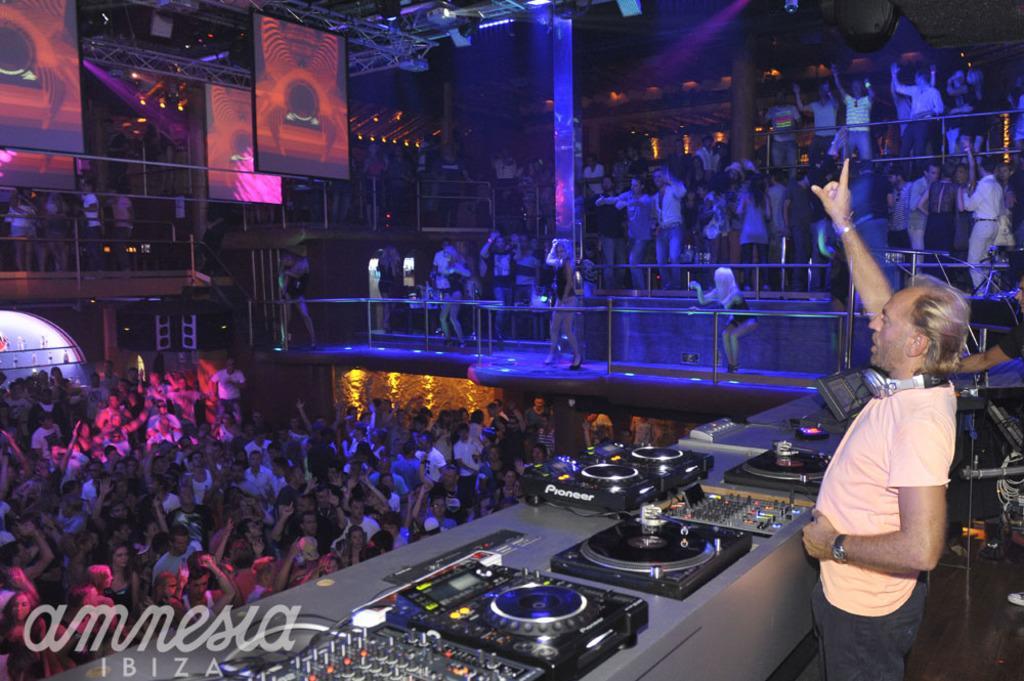Could you give a brief overview of what you see in this image? In this picture we can see a man standing on the floor. In front of him we can see a group of people, devices, railings, lights, boards and some objects. In the background it is dark. 